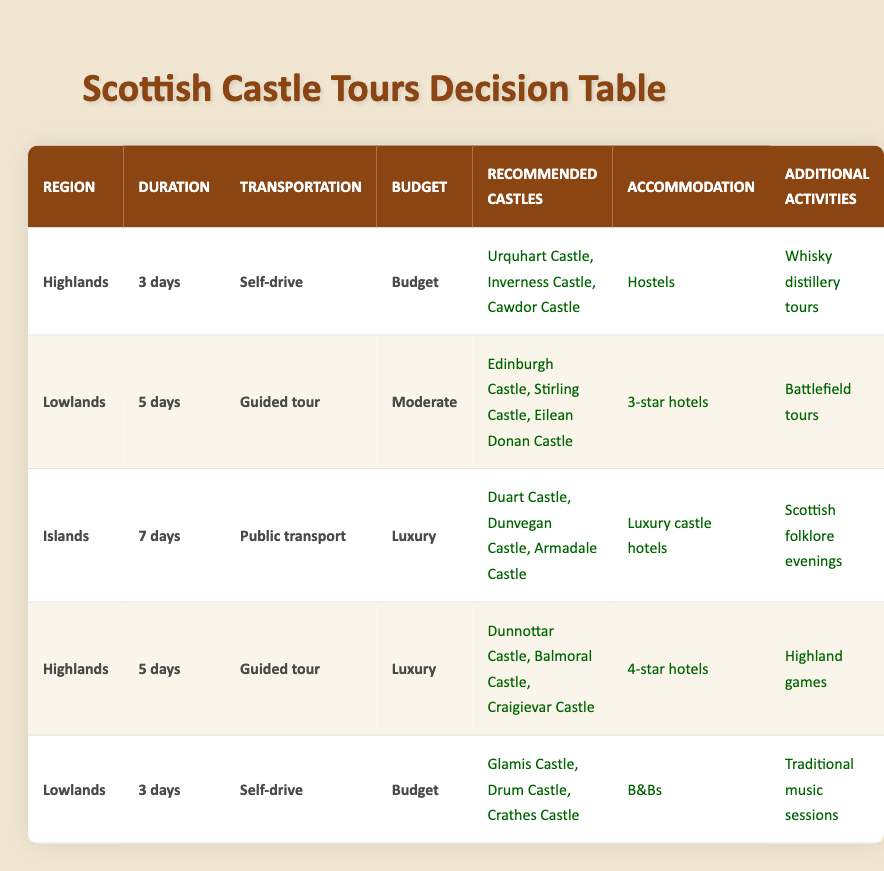What castles are recommended for a 5-day guided tour in the Lowlands on a moderate budget? The table shows that for a 5-day guided tour in the Lowlands with a moderate budget, the recommended castles are Edinburgh Castle, Stirling Castle, and Eilean Donan Castle.
Answer: Edinburgh Castle, Stirling Castle, Eilean Donan Castle For a 3-day self-drive trip on a budget in the Highlands, what additional activity is included? According to the table, for a 3-day self-drive trip on a budget in the Highlands, the additional activity is whisky distillery tours.
Answer: Whisky distillery tours Is there a luxury accommodation option for a 7-day public transport trip in the Islands? Yes, the table indicates that for a 7-day public transport trip in the Islands, the accommodation option is luxury castle hotels.
Answer: Yes What is the common mode of transportation for both the 5-day guided tour in the Lowlands and the luxury trip to the Islands? In the table, the mode of transportation for the 5-day guided tour in the Lowlands is a guided tour, while the luxury trip to the Islands uses public transport. Since these are different transportation methods, there is no common mode.
Answer: No How many different types of additional activities are provided in the table? The table lists five different types of additional activities: whisky distillery tours, Highland games, Scottish folklore evenings, battlefield tours, and traditional music sessions. Counting these options gives us a total of five different activities.
Answer: 5 For a 7-day duration trip in the Islands with a luxury budget, what castles and activities are recommended? The table shows that for a 7-day duration trip in the Islands with a luxury budget, the recommended castles are Duart Castle, Dunvegan Castle, and Armadale Castle, and the additional activity is Scottish folklore evenings.
Answer: Duart Castle, Dunvegan Castle, Armadale Castle; Scottish folklore evenings Are there any budget-friendly options for a 3-day trip in the Lowlands that include B&B accommodations? The table indicates that for a 3-day trip in the Lowlands on a budget, the accommodation option is B&Bs, therefore there are budget-friendly options available.
Answer: Yes Which castle is included in both the recommended castles for a 3-day self-drive trip in the Lowlands and the 5-day guided trip in the Lowlands? By examining the table, it becomes clear that the castles for the 3-day self-drive trip are Glamis Castle, Drum Castle, and Crathes Castle, while the 5-day guided trip includes Edinburgh Castle, Stirling Castle, and Eilean Donan Castle. There are no common castles between these two trips.
Answer: No 